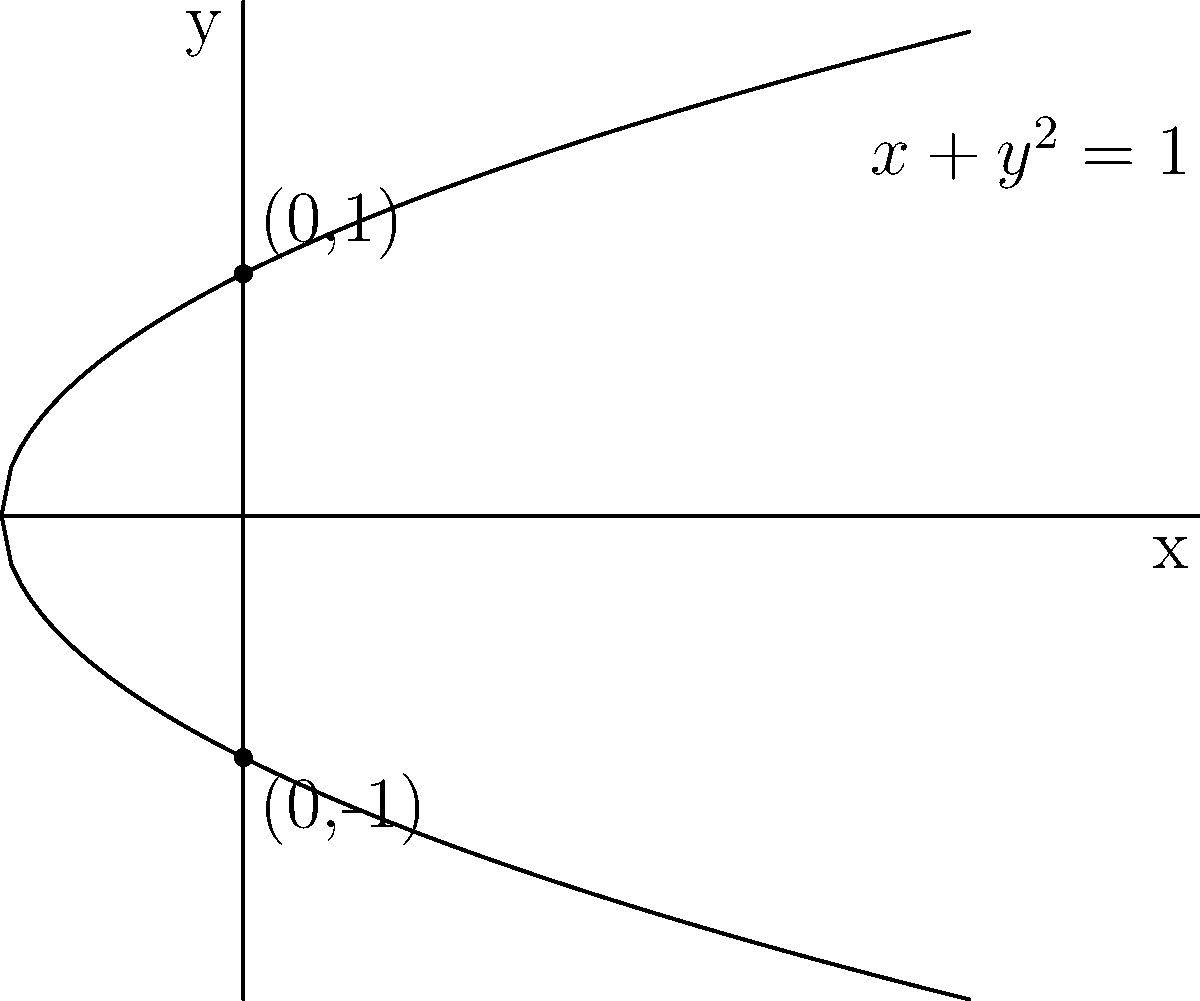Consider the equation $x+y^2=1$. Identify the type of conic section this represents and state its key properties. Let's approach this step-by-step:

1) First, we need to recognize the standard form of this equation. The general form of a conic section is $Ax^2 + Bxy + Cy^2 + Dx + Ey + F = 0$.

2) Our equation $x+y^2=1$ can be rearranged to $y^2 = -x + 1$ or $y^2 = 1 - x$.

3) This is in the form $y^2 = 2px$, where $p = -\frac{1}{2}$. This is the standard form of a parabola with its axis of symmetry parallel to the y-axis.

4) Key properties of this parabola:
   a) The vertex is at (1,0), as this is the point where x is maximum.
   b) The focus is $(\frac{1}{2},0)$, as it's $\frac{|p|}{2} = \frac{1}{4}$ to the left of the vertex.
   c) The directrix is the line $x = \frac{3}{2}$, as it's $\frac{|p|}{2} = \frac{1}{4}$ to the right of the vertex.
   d) The parabola opens to the left because $p$ is negative.

5) The y-intercepts are at (0,1) and (0,-1), as can be seen by setting x=0 in the equation.

6) There is no x-intercept other than the vertex (1,0), as the parabola doesn't cross the x-axis at any other point.

Therefore, this equation represents a parabola with its axis of symmetry parallel to the y-axis, opening to the left.
Answer: Parabola opening left; vertex (1,0), focus $(\frac{1}{2},0)$, directrix $x=\frac{3}{2}$ 